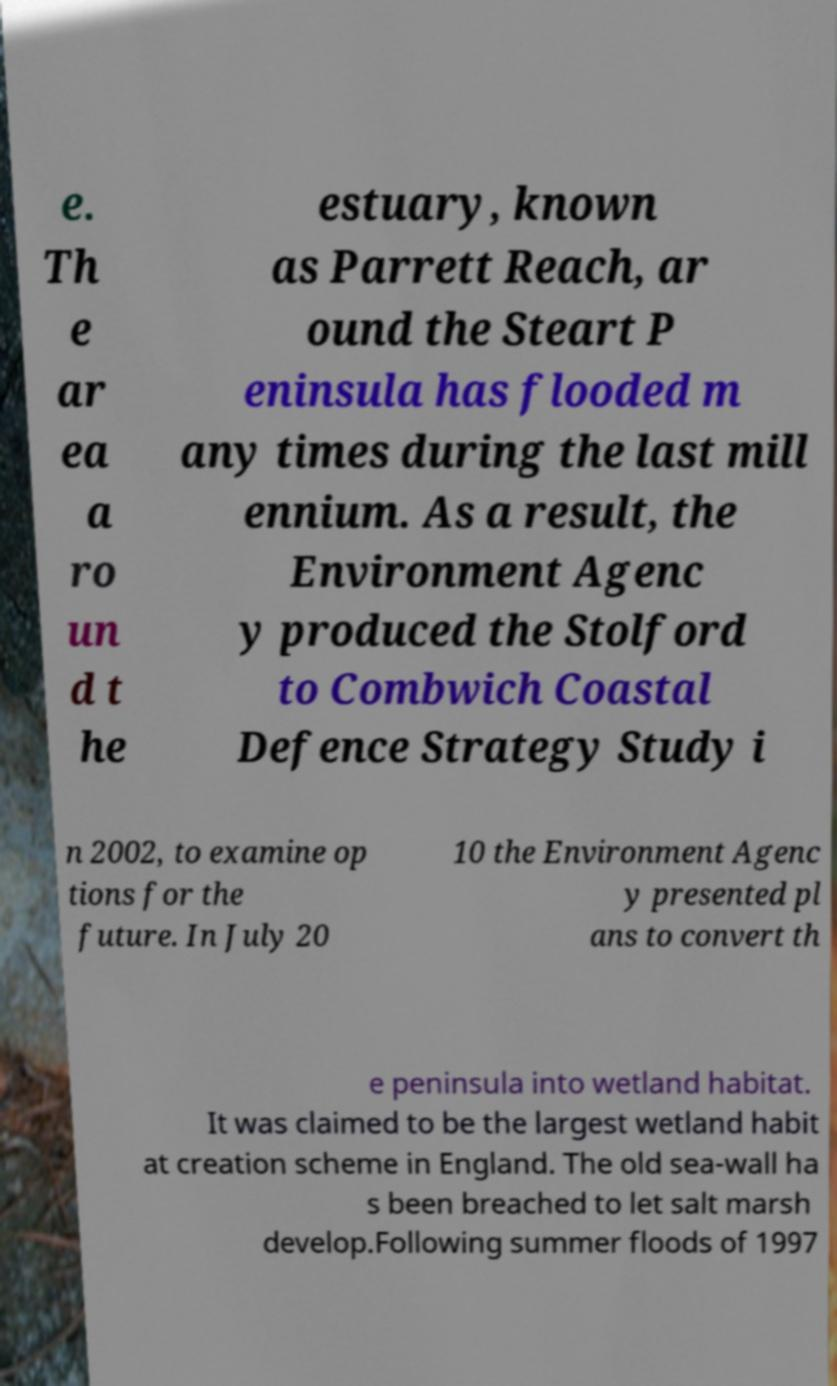Can you accurately transcribe the text from the provided image for me? e. Th e ar ea a ro un d t he estuary, known as Parrett Reach, ar ound the Steart P eninsula has flooded m any times during the last mill ennium. As a result, the Environment Agenc y produced the Stolford to Combwich Coastal Defence Strategy Study i n 2002, to examine op tions for the future. In July 20 10 the Environment Agenc y presented pl ans to convert th e peninsula into wetland habitat. It was claimed to be the largest wetland habit at creation scheme in England. The old sea-wall ha s been breached to let salt marsh develop.Following summer floods of 1997 